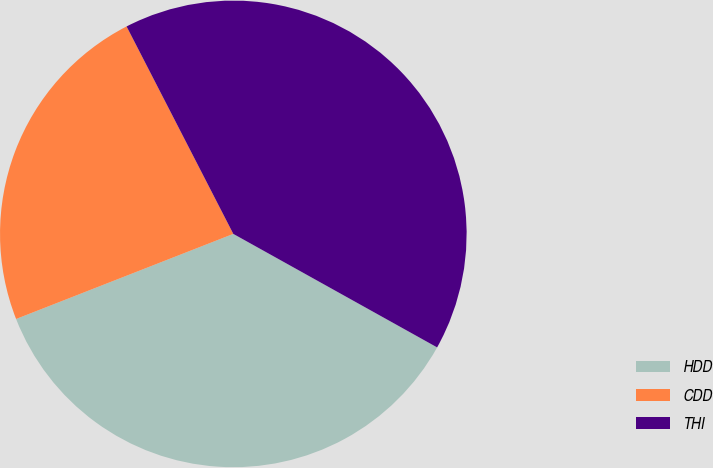<chart> <loc_0><loc_0><loc_500><loc_500><pie_chart><fcel>HDD<fcel>CDD<fcel>THI<nl><fcel>35.97%<fcel>23.38%<fcel>40.65%<nl></chart> 